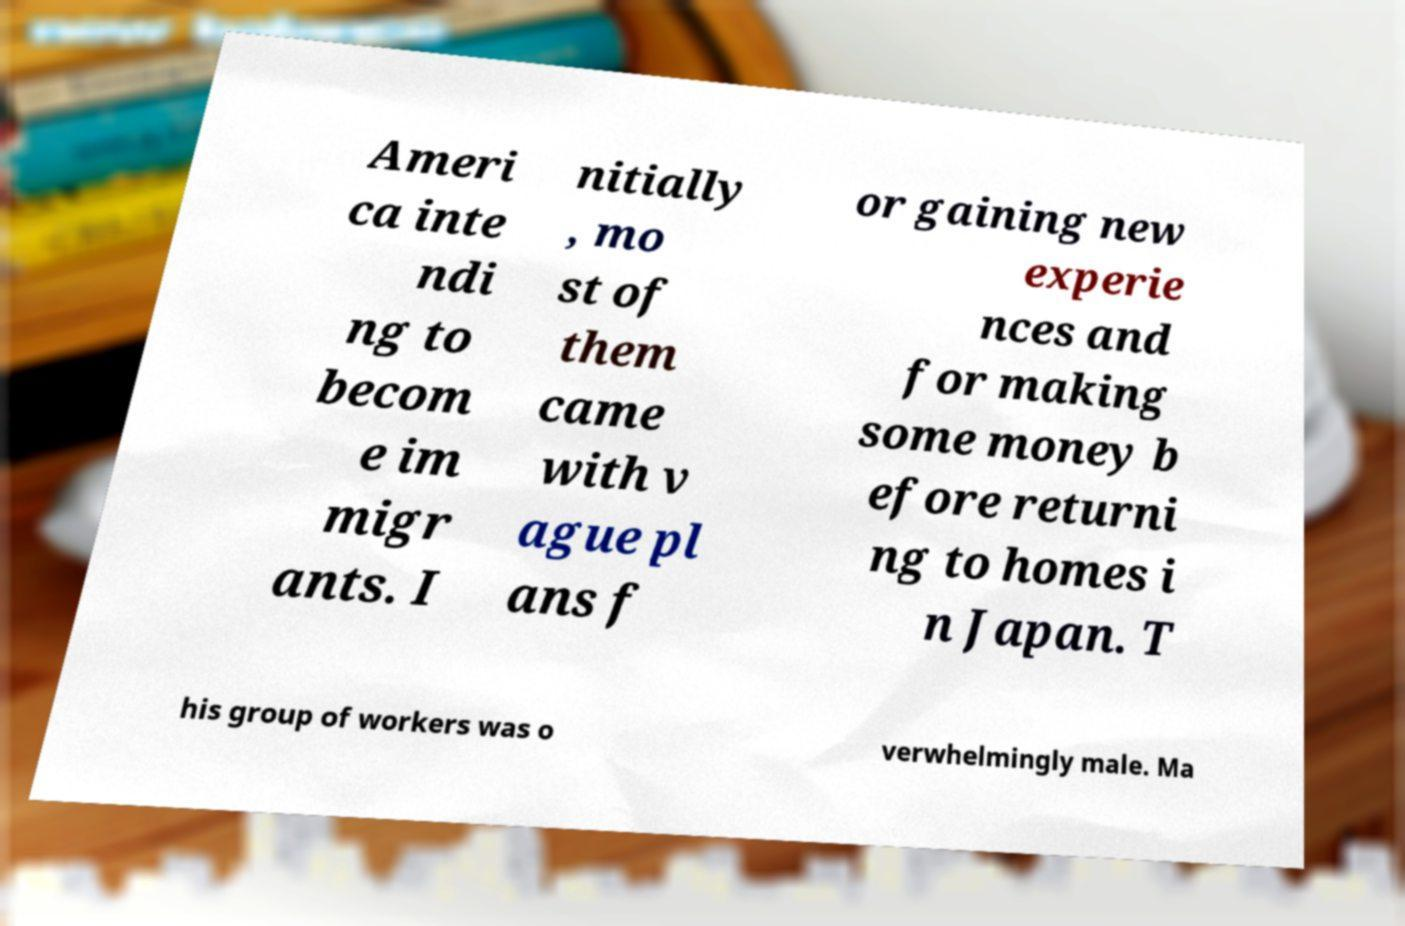What messages or text are displayed in this image? I need them in a readable, typed format. Ameri ca inte ndi ng to becom e im migr ants. I nitially , mo st of them came with v ague pl ans f or gaining new experie nces and for making some money b efore returni ng to homes i n Japan. T his group of workers was o verwhelmingly male. Ma 